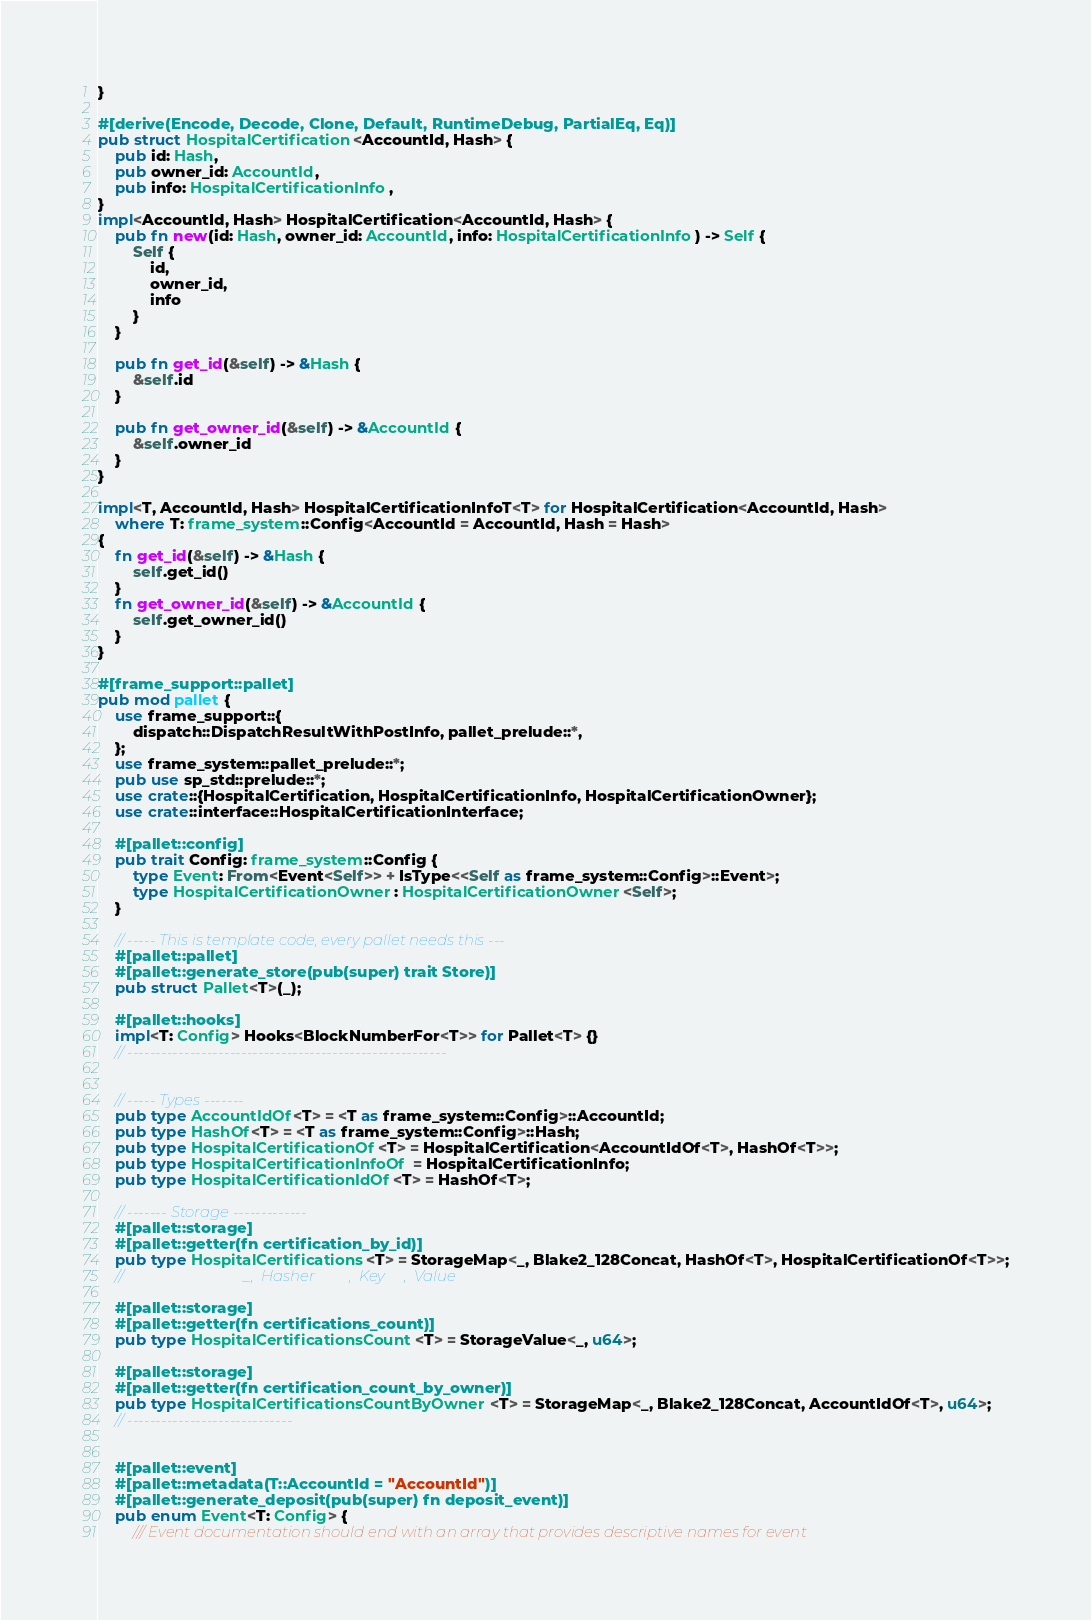Convert code to text. <code><loc_0><loc_0><loc_500><loc_500><_Rust_>}

#[derive(Encode, Decode, Clone, Default, RuntimeDebug, PartialEq, Eq)]
pub struct HospitalCertification<AccountId, Hash> {
    pub id: Hash,
    pub owner_id: AccountId,
    pub info: HospitalCertificationInfo,
}
impl<AccountId, Hash> HospitalCertification<AccountId, Hash> {
    pub fn new(id: Hash, owner_id: AccountId, info: HospitalCertificationInfo) -> Self {
        Self {
            id,
            owner_id,
            info
        }
    }

    pub fn get_id(&self) -> &Hash {
        &self.id
    }

    pub fn get_owner_id(&self) -> &AccountId {
        &self.owner_id
    }
}

impl<T, AccountId, Hash> HospitalCertificationInfoT<T> for HospitalCertification<AccountId, Hash>
    where T: frame_system::Config<AccountId = AccountId, Hash = Hash>
{
    fn get_id(&self) -> &Hash {
        self.get_id()
    }
    fn get_owner_id(&self) -> &AccountId {
        self.get_owner_id()
    }
}

#[frame_support::pallet]
pub mod pallet {
    use frame_support::{
        dispatch::DispatchResultWithPostInfo, pallet_prelude::*,
    };
    use frame_system::pallet_prelude::*;
    pub use sp_std::prelude::*;
    use crate::{HospitalCertification, HospitalCertificationInfo, HospitalCertificationOwner};
    use crate::interface::HospitalCertificationInterface;

    #[pallet::config]
    pub trait Config: frame_system::Config {
        type Event: From<Event<Self>> + IsType<<Self as frame_system::Config>::Event>;
        type HospitalCertificationOwner: HospitalCertificationOwner<Self>;
    }

    // ----- This is template code, every pallet needs this ---
    #[pallet::pallet]
    #[pallet::generate_store(pub(super) trait Store)]
    pub struct Pallet<T>(_);

    #[pallet::hooks]
    impl<T: Config> Hooks<BlockNumberFor<T>> for Pallet<T> {}
    // --------------------------------------------------------
    

    // ----- Types -------
    pub type AccountIdOf<T> = <T as frame_system::Config>::AccountId;
    pub type HashOf<T> = <T as frame_system::Config>::Hash;
    pub type HospitalCertificationOf<T> = HospitalCertification<AccountIdOf<T>, HashOf<T>>;
    pub type HospitalCertificationInfoOf = HospitalCertificationInfo;
    pub type HospitalCertificationIdOf<T> = HashOf<T>;

    // ------- Storage -------------
    #[pallet::storage]
    #[pallet::getter(fn certification_by_id)]
    pub type HospitalCertifications<T> = StorageMap<_, Blake2_128Concat, HashOf<T>, HospitalCertificationOf<T>>;
    //                                _,  Hasher         ,  Key     ,  Value

    #[pallet::storage]
    #[pallet::getter(fn certifications_count)]
    pub type HospitalCertificationsCount<T> = StorageValue<_, u64>;

    #[pallet::storage]
    #[pallet::getter(fn certification_count_by_owner)]
    pub type HospitalCertificationsCountByOwner<T> = StorageMap<_, Blake2_128Concat, AccountIdOf<T>, u64>;
    // -----------------------------


    #[pallet::event]
    #[pallet::metadata(T::AccountId = "AccountId")]
    #[pallet::generate_deposit(pub(super) fn deposit_event)]
    pub enum Event<T: Config> {
        /// Event documentation should end with an array that provides descriptive names for event</code> 